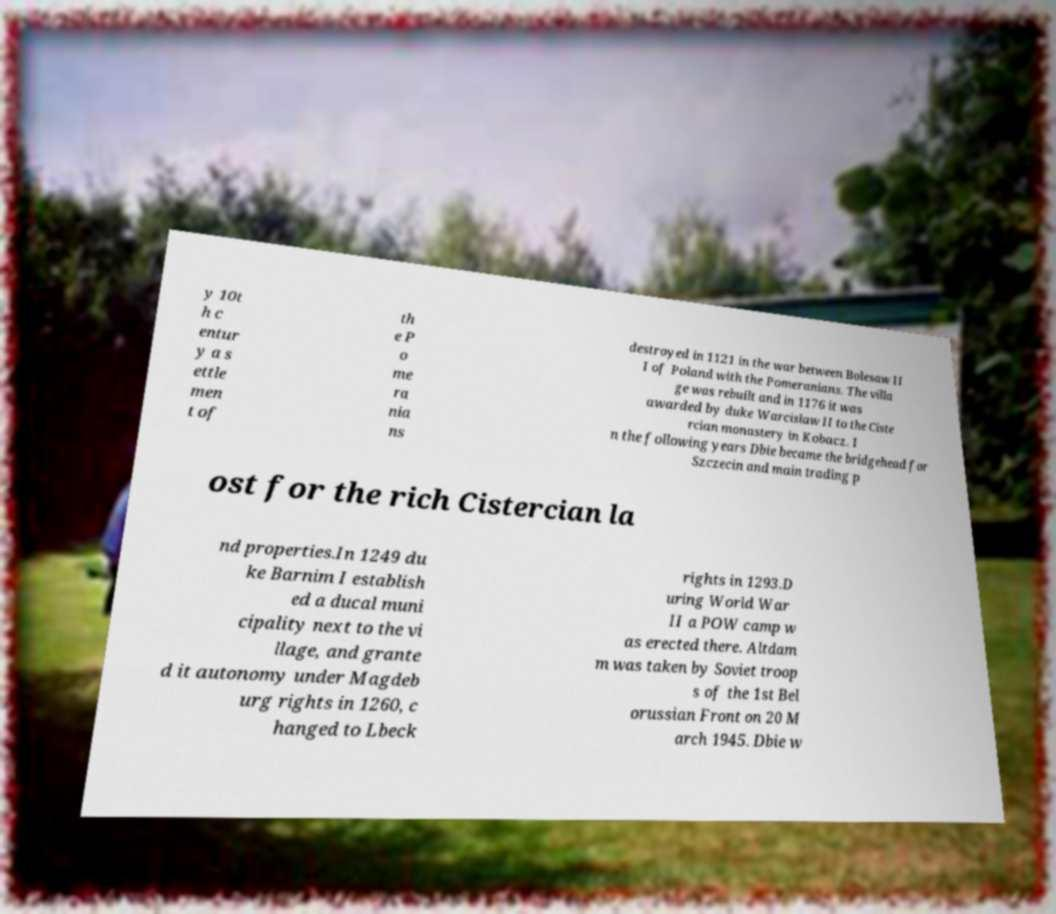Could you assist in decoding the text presented in this image and type it out clearly? y 10t h c entur y a s ettle men t of th e P o me ra nia ns destroyed in 1121 in the war between Bolesaw II I of Poland with the Pomeranians. The villa ge was rebuilt and in 1176 it was awarded by duke Warcislaw II to the Ciste rcian monastery in Kobacz. I n the following years Dbie became the bridgehead for Szczecin and main trading p ost for the rich Cistercian la nd properties.In 1249 du ke Barnim I establish ed a ducal muni cipality next to the vi llage, and grante d it autonomy under Magdeb urg rights in 1260, c hanged to Lbeck rights in 1293.D uring World War II a POW camp w as erected there. Altdam m was taken by Soviet troop s of the 1st Bel orussian Front on 20 M arch 1945. Dbie w 